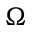<formula> <loc_0><loc_0><loc_500><loc_500>\Omega</formula> 